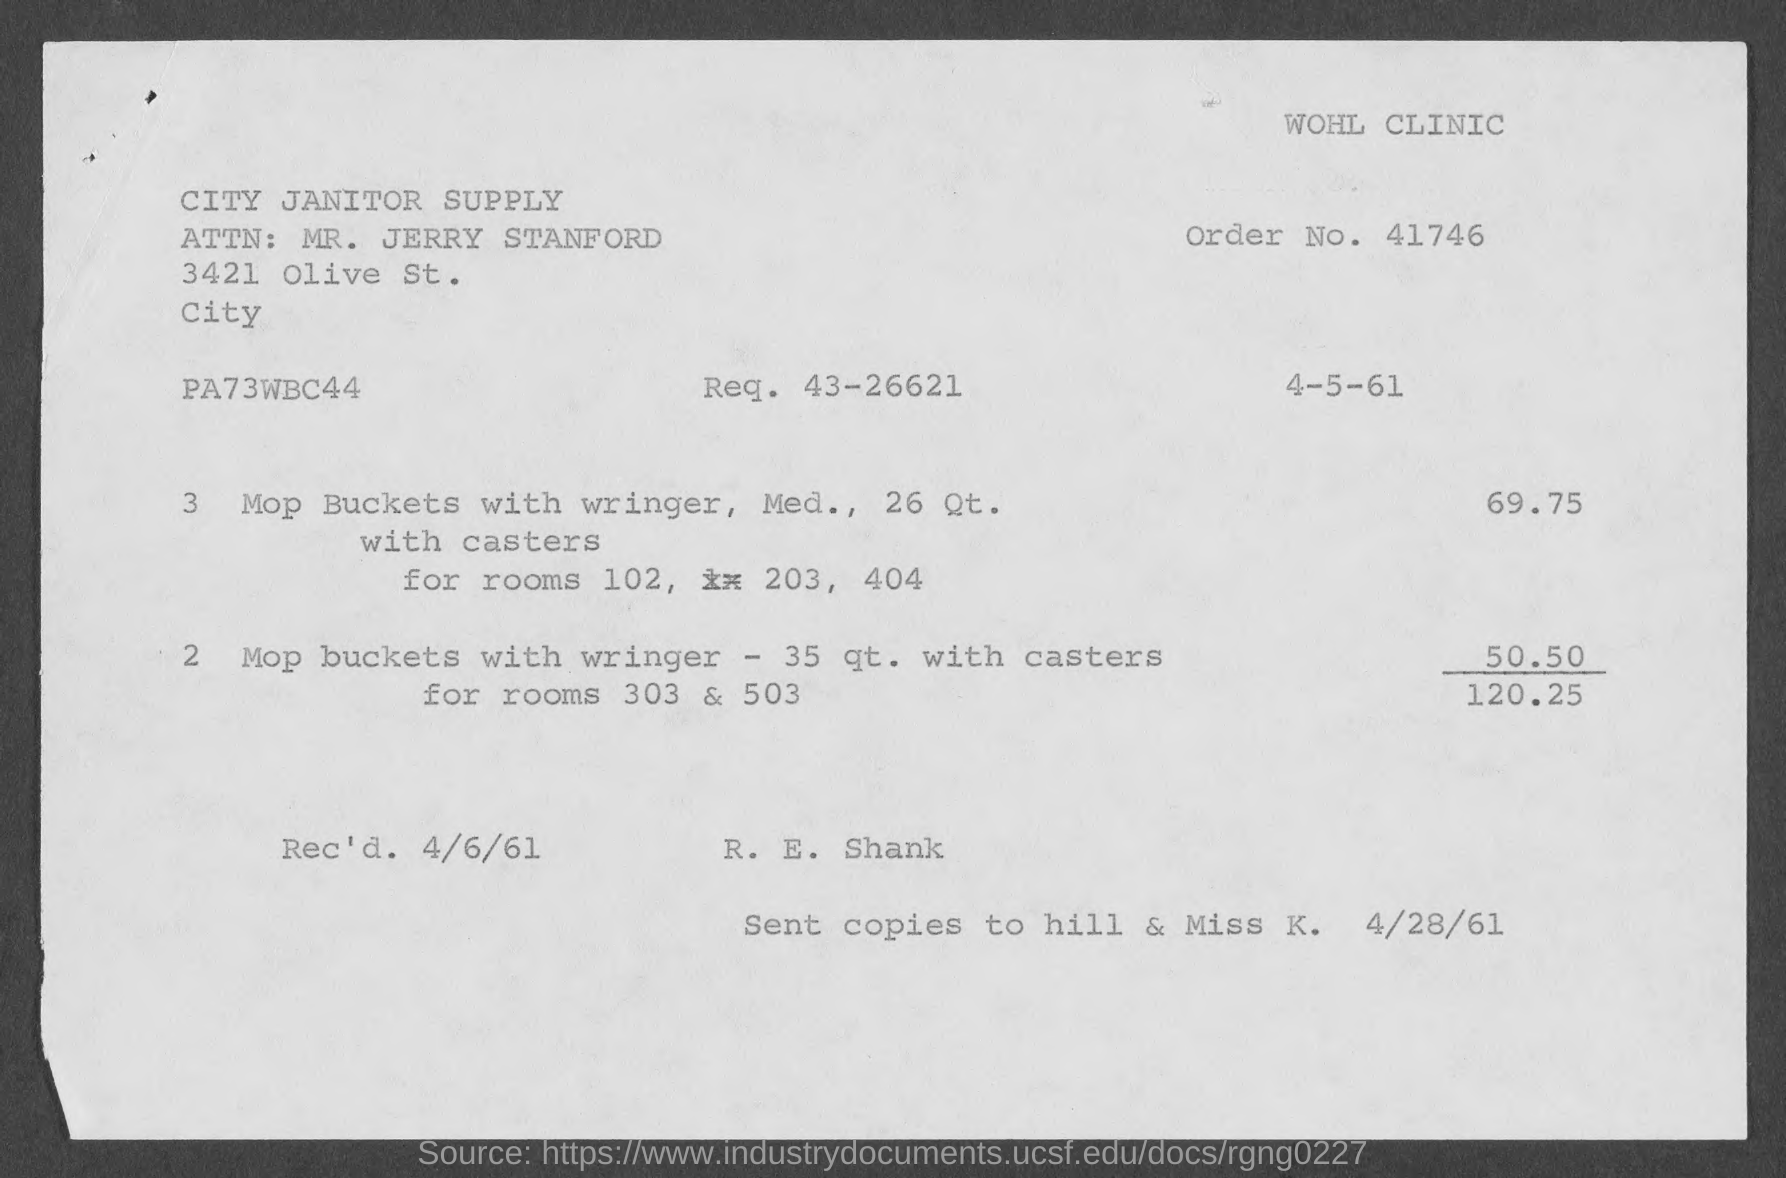What is the Req. No. given in the invoice?
Your answer should be compact. 43-26621. What is the Order No. given in the invoice?
Ensure brevity in your answer.  41746. What is the received date mentioned in the invoice?
Make the answer very short. 4/6/61. What is the total invoice amount given in the document?
Provide a succinct answer. 120.25. 